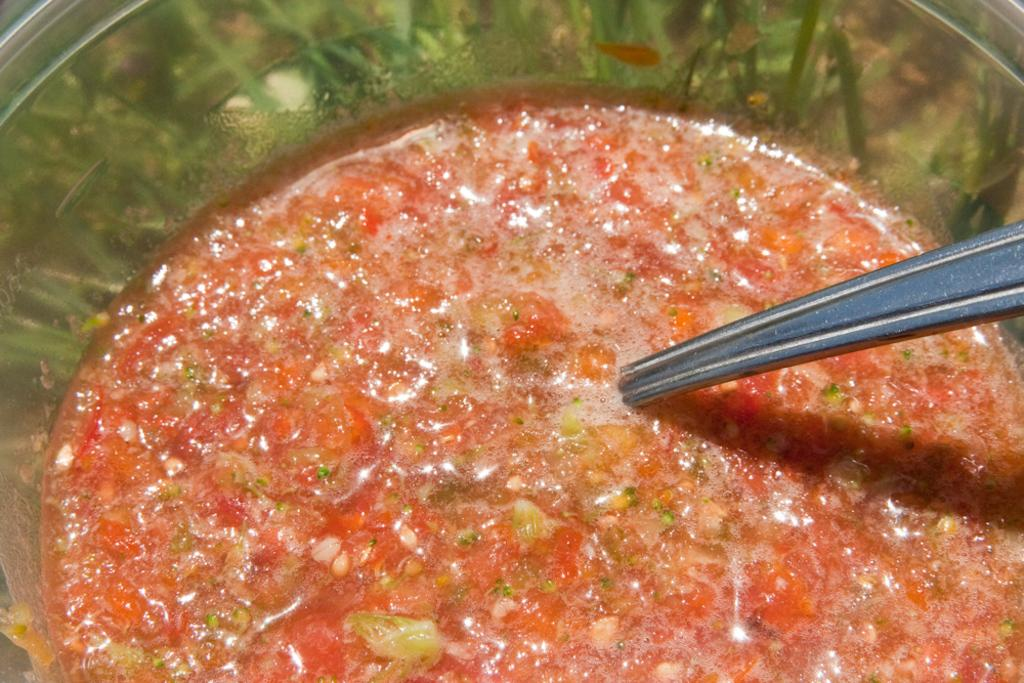What is the main subject of the image? The main subject of the image is food. How is the food presented in the image? The food is in a bowl. What utensil is visible in the image? There is a spoon in the image. What type of class is being taught in the image? There is no class or teaching activity depicted in the image; it features food in a bowl with a spoon. What color are the trousers worn by the person in the image? There is no person present in the image, so it is not possible to determine the color of their trousers. 